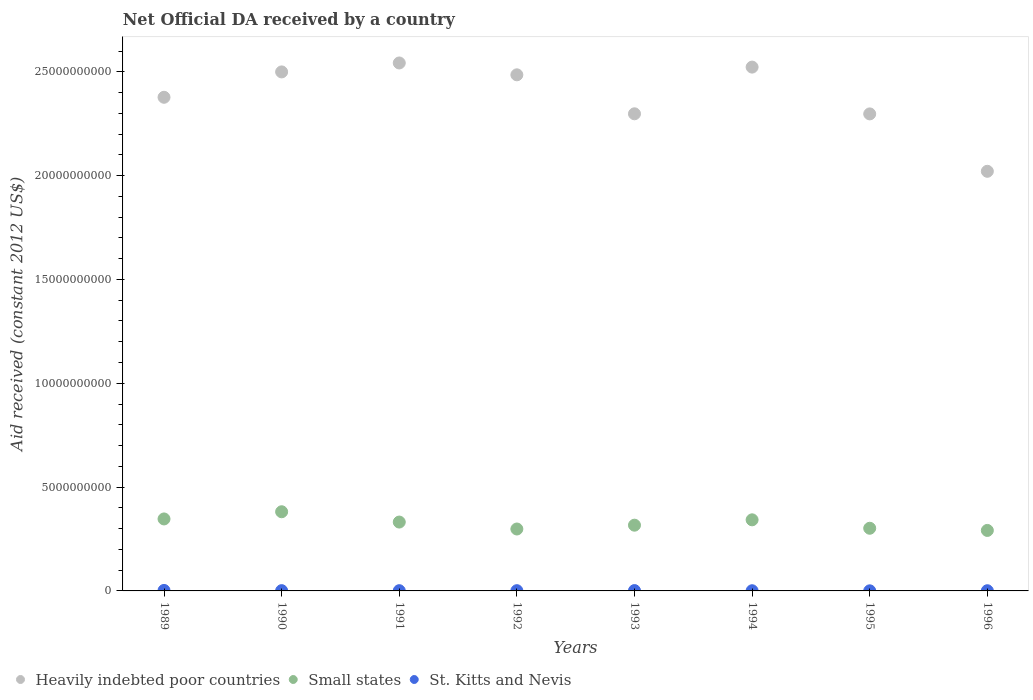How many different coloured dotlines are there?
Provide a succinct answer. 3. What is the net official development assistance aid received in St. Kitts and Nevis in 1994?
Provide a succinct answer. 9.11e+06. Across all years, what is the maximum net official development assistance aid received in Heavily indebted poor countries?
Offer a very short reply. 2.54e+1. Across all years, what is the minimum net official development assistance aid received in Small states?
Provide a short and direct response. 2.91e+09. In which year was the net official development assistance aid received in Small states maximum?
Offer a very short reply. 1990. In which year was the net official development assistance aid received in Small states minimum?
Your response must be concise. 1996. What is the total net official development assistance aid received in St. Kitts and Nevis in the graph?
Offer a terse response. 9.91e+07. What is the difference between the net official development assistance aid received in Heavily indebted poor countries in 1991 and that in 1992?
Keep it short and to the point. 5.71e+08. What is the difference between the net official development assistance aid received in Heavily indebted poor countries in 1991 and the net official development assistance aid received in Small states in 1989?
Keep it short and to the point. 2.20e+1. What is the average net official development assistance aid received in St. Kitts and Nevis per year?
Keep it short and to the point. 1.24e+07. In the year 1992, what is the difference between the net official development assistance aid received in Small states and net official development assistance aid received in Heavily indebted poor countries?
Give a very brief answer. -2.19e+1. In how many years, is the net official development assistance aid received in Small states greater than 5000000000 US$?
Keep it short and to the point. 0. What is the ratio of the net official development assistance aid received in Small states in 1991 to that in 1992?
Provide a succinct answer. 1.11. Is the net official development assistance aid received in Heavily indebted poor countries in 1992 less than that in 1995?
Your answer should be very brief. No. Is the difference between the net official development assistance aid received in Small states in 1992 and 1996 greater than the difference between the net official development assistance aid received in Heavily indebted poor countries in 1992 and 1996?
Provide a succinct answer. No. What is the difference between the highest and the second highest net official development assistance aid received in Small states?
Provide a short and direct response. 3.46e+08. What is the difference between the highest and the lowest net official development assistance aid received in St. Kitts and Nevis?
Offer a terse response. 1.82e+07. In how many years, is the net official development assistance aid received in Small states greater than the average net official development assistance aid received in Small states taken over all years?
Offer a very short reply. 4. Is it the case that in every year, the sum of the net official development assistance aid received in Small states and net official development assistance aid received in Heavily indebted poor countries  is greater than the net official development assistance aid received in St. Kitts and Nevis?
Your answer should be compact. Yes. Does the net official development assistance aid received in St. Kitts and Nevis monotonically increase over the years?
Keep it short and to the point. No. Is the net official development assistance aid received in Small states strictly greater than the net official development assistance aid received in Heavily indebted poor countries over the years?
Your answer should be very brief. No. Is the net official development assistance aid received in St. Kitts and Nevis strictly less than the net official development assistance aid received in Heavily indebted poor countries over the years?
Your response must be concise. Yes. How many dotlines are there?
Offer a very short reply. 3. How many years are there in the graph?
Provide a short and direct response. 8. What is the difference between two consecutive major ticks on the Y-axis?
Keep it short and to the point. 5.00e+09. Are the values on the major ticks of Y-axis written in scientific E-notation?
Make the answer very short. No. Does the graph contain grids?
Provide a succinct answer. No. Where does the legend appear in the graph?
Your answer should be very brief. Bottom left. How many legend labels are there?
Your response must be concise. 3. How are the legend labels stacked?
Provide a succinct answer. Horizontal. What is the title of the graph?
Provide a short and direct response. Net Official DA received by a country. What is the label or title of the X-axis?
Provide a succinct answer. Years. What is the label or title of the Y-axis?
Keep it short and to the point. Aid received (constant 2012 US$). What is the Aid received (constant 2012 US$) in Heavily indebted poor countries in 1989?
Ensure brevity in your answer.  2.38e+1. What is the Aid received (constant 2012 US$) in Small states in 1989?
Ensure brevity in your answer.  3.47e+09. What is the Aid received (constant 2012 US$) in St. Kitts and Nevis in 1989?
Keep it short and to the point. 2.32e+07. What is the Aid received (constant 2012 US$) of Heavily indebted poor countries in 1990?
Ensure brevity in your answer.  2.50e+1. What is the Aid received (constant 2012 US$) of Small states in 1990?
Keep it short and to the point. 3.81e+09. What is the Aid received (constant 2012 US$) of St. Kitts and Nevis in 1990?
Offer a very short reply. 1.31e+07. What is the Aid received (constant 2012 US$) of Heavily indebted poor countries in 1991?
Keep it short and to the point. 2.54e+1. What is the Aid received (constant 2012 US$) in Small states in 1991?
Keep it short and to the point. 3.32e+09. What is the Aid received (constant 2012 US$) of St. Kitts and Nevis in 1991?
Your answer should be very brief. 1.15e+07. What is the Aid received (constant 2012 US$) in Heavily indebted poor countries in 1992?
Provide a short and direct response. 2.49e+1. What is the Aid received (constant 2012 US$) of Small states in 1992?
Make the answer very short. 2.98e+09. What is the Aid received (constant 2012 US$) in St. Kitts and Nevis in 1992?
Make the answer very short. 1.18e+07. What is the Aid received (constant 2012 US$) of Heavily indebted poor countries in 1993?
Offer a very short reply. 2.30e+1. What is the Aid received (constant 2012 US$) in Small states in 1993?
Provide a succinct answer. 3.17e+09. What is the Aid received (constant 2012 US$) in St. Kitts and Nevis in 1993?
Your answer should be compact. 1.62e+07. What is the Aid received (constant 2012 US$) of Heavily indebted poor countries in 1994?
Keep it short and to the point. 2.52e+1. What is the Aid received (constant 2012 US$) of Small states in 1994?
Ensure brevity in your answer.  3.42e+09. What is the Aid received (constant 2012 US$) in St. Kitts and Nevis in 1994?
Offer a very short reply. 9.11e+06. What is the Aid received (constant 2012 US$) of Heavily indebted poor countries in 1995?
Your answer should be very brief. 2.30e+1. What is the Aid received (constant 2012 US$) in Small states in 1995?
Give a very brief answer. 3.02e+09. What is the Aid received (constant 2012 US$) of St. Kitts and Nevis in 1995?
Give a very brief answer. 5.01e+06. What is the Aid received (constant 2012 US$) in Heavily indebted poor countries in 1996?
Ensure brevity in your answer.  2.02e+1. What is the Aid received (constant 2012 US$) of Small states in 1996?
Provide a short and direct response. 2.91e+09. What is the Aid received (constant 2012 US$) in St. Kitts and Nevis in 1996?
Give a very brief answer. 9.19e+06. Across all years, what is the maximum Aid received (constant 2012 US$) of Heavily indebted poor countries?
Give a very brief answer. 2.54e+1. Across all years, what is the maximum Aid received (constant 2012 US$) of Small states?
Make the answer very short. 3.81e+09. Across all years, what is the maximum Aid received (constant 2012 US$) of St. Kitts and Nevis?
Your answer should be compact. 2.32e+07. Across all years, what is the minimum Aid received (constant 2012 US$) in Heavily indebted poor countries?
Make the answer very short. 2.02e+1. Across all years, what is the minimum Aid received (constant 2012 US$) of Small states?
Offer a terse response. 2.91e+09. Across all years, what is the minimum Aid received (constant 2012 US$) of St. Kitts and Nevis?
Provide a succinct answer. 5.01e+06. What is the total Aid received (constant 2012 US$) of Heavily indebted poor countries in the graph?
Offer a very short reply. 1.90e+11. What is the total Aid received (constant 2012 US$) in Small states in the graph?
Offer a terse response. 2.61e+1. What is the total Aid received (constant 2012 US$) of St. Kitts and Nevis in the graph?
Ensure brevity in your answer.  9.91e+07. What is the difference between the Aid received (constant 2012 US$) in Heavily indebted poor countries in 1989 and that in 1990?
Your answer should be very brief. -1.22e+09. What is the difference between the Aid received (constant 2012 US$) of Small states in 1989 and that in 1990?
Keep it short and to the point. -3.46e+08. What is the difference between the Aid received (constant 2012 US$) in St. Kitts and Nevis in 1989 and that in 1990?
Your answer should be compact. 1.01e+07. What is the difference between the Aid received (constant 2012 US$) of Heavily indebted poor countries in 1989 and that in 1991?
Keep it short and to the point. -1.65e+09. What is the difference between the Aid received (constant 2012 US$) of Small states in 1989 and that in 1991?
Make the answer very short. 1.50e+08. What is the difference between the Aid received (constant 2012 US$) in St. Kitts and Nevis in 1989 and that in 1991?
Provide a succinct answer. 1.17e+07. What is the difference between the Aid received (constant 2012 US$) of Heavily indebted poor countries in 1989 and that in 1992?
Provide a succinct answer. -1.08e+09. What is the difference between the Aid received (constant 2012 US$) in Small states in 1989 and that in 1992?
Make the answer very short. 4.85e+08. What is the difference between the Aid received (constant 2012 US$) in St. Kitts and Nevis in 1989 and that in 1992?
Your answer should be very brief. 1.14e+07. What is the difference between the Aid received (constant 2012 US$) in Heavily indebted poor countries in 1989 and that in 1993?
Provide a short and direct response. 7.96e+08. What is the difference between the Aid received (constant 2012 US$) in Small states in 1989 and that in 1993?
Give a very brief answer. 3.01e+08. What is the difference between the Aid received (constant 2012 US$) of St. Kitts and Nevis in 1989 and that in 1993?
Offer a terse response. 6.94e+06. What is the difference between the Aid received (constant 2012 US$) in Heavily indebted poor countries in 1989 and that in 1994?
Provide a short and direct response. -1.45e+09. What is the difference between the Aid received (constant 2012 US$) in Small states in 1989 and that in 1994?
Provide a succinct answer. 4.28e+07. What is the difference between the Aid received (constant 2012 US$) of St. Kitts and Nevis in 1989 and that in 1994?
Your answer should be very brief. 1.41e+07. What is the difference between the Aid received (constant 2012 US$) in Heavily indebted poor countries in 1989 and that in 1995?
Your answer should be compact. 8.00e+08. What is the difference between the Aid received (constant 2012 US$) in Small states in 1989 and that in 1995?
Your answer should be compact. 4.49e+08. What is the difference between the Aid received (constant 2012 US$) of St. Kitts and Nevis in 1989 and that in 1995?
Give a very brief answer. 1.82e+07. What is the difference between the Aid received (constant 2012 US$) in Heavily indebted poor countries in 1989 and that in 1996?
Your response must be concise. 3.56e+09. What is the difference between the Aid received (constant 2012 US$) in Small states in 1989 and that in 1996?
Offer a very short reply. 5.54e+08. What is the difference between the Aid received (constant 2012 US$) of St. Kitts and Nevis in 1989 and that in 1996?
Offer a terse response. 1.40e+07. What is the difference between the Aid received (constant 2012 US$) in Heavily indebted poor countries in 1990 and that in 1991?
Provide a short and direct response. -4.31e+08. What is the difference between the Aid received (constant 2012 US$) in Small states in 1990 and that in 1991?
Your answer should be very brief. 4.96e+08. What is the difference between the Aid received (constant 2012 US$) of St. Kitts and Nevis in 1990 and that in 1991?
Offer a very short reply. 1.62e+06. What is the difference between the Aid received (constant 2012 US$) of Heavily indebted poor countries in 1990 and that in 1992?
Your answer should be compact. 1.40e+08. What is the difference between the Aid received (constant 2012 US$) in Small states in 1990 and that in 1992?
Keep it short and to the point. 8.31e+08. What is the difference between the Aid received (constant 2012 US$) of St. Kitts and Nevis in 1990 and that in 1992?
Ensure brevity in your answer.  1.35e+06. What is the difference between the Aid received (constant 2012 US$) in Heavily indebted poor countries in 1990 and that in 1993?
Your response must be concise. 2.02e+09. What is the difference between the Aid received (constant 2012 US$) of Small states in 1990 and that in 1993?
Provide a short and direct response. 6.47e+08. What is the difference between the Aid received (constant 2012 US$) in St. Kitts and Nevis in 1990 and that in 1993?
Give a very brief answer. -3.14e+06. What is the difference between the Aid received (constant 2012 US$) in Heavily indebted poor countries in 1990 and that in 1994?
Keep it short and to the point. -2.32e+08. What is the difference between the Aid received (constant 2012 US$) of Small states in 1990 and that in 1994?
Your answer should be compact. 3.89e+08. What is the difference between the Aid received (constant 2012 US$) of Heavily indebted poor countries in 1990 and that in 1995?
Keep it short and to the point. 2.02e+09. What is the difference between the Aid received (constant 2012 US$) of Small states in 1990 and that in 1995?
Keep it short and to the point. 7.95e+08. What is the difference between the Aid received (constant 2012 US$) of St. Kitts and Nevis in 1990 and that in 1995?
Your answer should be compact. 8.10e+06. What is the difference between the Aid received (constant 2012 US$) of Heavily indebted poor countries in 1990 and that in 1996?
Make the answer very short. 4.79e+09. What is the difference between the Aid received (constant 2012 US$) of Small states in 1990 and that in 1996?
Offer a very short reply. 8.99e+08. What is the difference between the Aid received (constant 2012 US$) of St. Kitts and Nevis in 1990 and that in 1996?
Your response must be concise. 3.92e+06. What is the difference between the Aid received (constant 2012 US$) in Heavily indebted poor countries in 1991 and that in 1992?
Your answer should be very brief. 5.71e+08. What is the difference between the Aid received (constant 2012 US$) of Small states in 1991 and that in 1992?
Keep it short and to the point. 3.34e+08. What is the difference between the Aid received (constant 2012 US$) in Heavily indebted poor countries in 1991 and that in 1993?
Ensure brevity in your answer.  2.45e+09. What is the difference between the Aid received (constant 2012 US$) in Small states in 1991 and that in 1993?
Give a very brief answer. 1.50e+08. What is the difference between the Aid received (constant 2012 US$) of St. Kitts and Nevis in 1991 and that in 1993?
Your answer should be very brief. -4.76e+06. What is the difference between the Aid received (constant 2012 US$) in Heavily indebted poor countries in 1991 and that in 1994?
Offer a very short reply. 1.99e+08. What is the difference between the Aid received (constant 2012 US$) in Small states in 1991 and that in 1994?
Ensure brevity in your answer.  -1.08e+08. What is the difference between the Aid received (constant 2012 US$) in St. Kitts and Nevis in 1991 and that in 1994?
Your response must be concise. 2.38e+06. What is the difference between the Aid received (constant 2012 US$) in Heavily indebted poor countries in 1991 and that in 1995?
Provide a short and direct response. 2.45e+09. What is the difference between the Aid received (constant 2012 US$) of Small states in 1991 and that in 1995?
Offer a terse response. 2.98e+08. What is the difference between the Aid received (constant 2012 US$) of St. Kitts and Nevis in 1991 and that in 1995?
Provide a short and direct response. 6.48e+06. What is the difference between the Aid received (constant 2012 US$) of Heavily indebted poor countries in 1991 and that in 1996?
Your answer should be compact. 5.22e+09. What is the difference between the Aid received (constant 2012 US$) of Small states in 1991 and that in 1996?
Make the answer very short. 4.03e+08. What is the difference between the Aid received (constant 2012 US$) in St. Kitts and Nevis in 1991 and that in 1996?
Your answer should be compact. 2.30e+06. What is the difference between the Aid received (constant 2012 US$) in Heavily indebted poor countries in 1992 and that in 1993?
Give a very brief answer. 1.88e+09. What is the difference between the Aid received (constant 2012 US$) in Small states in 1992 and that in 1993?
Keep it short and to the point. -1.84e+08. What is the difference between the Aid received (constant 2012 US$) of St. Kitts and Nevis in 1992 and that in 1993?
Your answer should be compact. -4.49e+06. What is the difference between the Aid received (constant 2012 US$) of Heavily indebted poor countries in 1992 and that in 1994?
Offer a terse response. -3.72e+08. What is the difference between the Aid received (constant 2012 US$) in Small states in 1992 and that in 1994?
Keep it short and to the point. -4.42e+08. What is the difference between the Aid received (constant 2012 US$) of St. Kitts and Nevis in 1992 and that in 1994?
Offer a very short reply. 2.65e+06. What is the difference between the Aid received (constant 2012 US$) in Heavily indebted poor countries in 1992 and that in 1995?
Keep it short and to the point. 1.88e+09. What is the difference between the Aid received (constant 2012 US$) of Small states in 1992 and that in 1995?
Ensure brevity in your answer.  -3.59e+07. What is the difference between the Aid received (constant 2012 US$) in St. Kitts and Nevis in 1992 and that in 1995?
Offer a terse response. 6.75e+06. What is the difference between the Aid received (constant 2012 US$) in Heavily indebted poor countries in 1992 and that in 1996?
Your answer should be very brief. 4.65e+09. What is the difference between the Aid received (constant 2012 US$) in Small states in 1992 and that in 1996?
Offer a terse response. 6.89e+07. What is the difference between the Aid received (constant 2012 US$) of St. Kitts and Nevis in 1992 and that in 1996?
Ensure brevity in your answer.  2.57e+06. What is the difference between the Aid received (constant 2012 US$) of Heavily indebted poor countries in 1993 and that in 1994?
Your answer should be compact. -2.25e+09. What is the difference between the Aid received (constant 2012 US$) in Small states in 1993 and that in 1994?
Make the answer very short. -2.58e+08. What is the difference between the Aid received (constant 2012 US$) of St. Kitts and Nevis in 1993 and that in 1994?
Offer a very short reply. 7.14e+06. What is the difference between the Aid received (constant 2012 US$) in Heavily indebted poor countries in 1993 and that in 1995?
Make the answer very short. 4.75e+06. What is the difference between the Aid received (constant 2012 US$) in Small states in 1993 and that in 1995?
Offer a very short reply. 1.48e+08. What is the difference between the Aid received (constant 2012 US$) in St. Kitts and Nevis in 1993 and that in 1995?
Provide a short and direct response. 1.12e+07. What is the difference between the Aid received (constant 2012 US$) of Heavily indebted poor countries in 1993 and that in 1996?
Your response must be concise. 2.77e+09. What is the difference between the Aid received (constant 2012 US$) in Small states in 1993 and that in 1996?
Keep it short and to the point. 2.53e+08. What is the difference between the Aid received (constant 2012 US$) in St. Kitts and Nevis in 1993 and that in 1996?
Give a very brief answer. 7.06e+06. What is the difference between the Aid received (constant 2012 US$) of Heavily indebted poor countries in 1994 and that in 1995?
Make the answer very short. 2.25e+09. What is the difference between the Aid received (constant 2012 US$) in Small states in 1994 and that in 1995?
Offer a very short reply. 4.06e+08. What is the difference between the Aid received (constant 2012 US$) in St. Kitts and Nevis in 1994 and that in 1995?
Offer a terse response. 4.10e+06. What is the difference between the Aid received (constant 2012 US$) in Heavily indebted poor countries in 1994 and that in 1996?
Your response must be concise. 5.02e+09. What is the difference between the Aid received (constant 2012 US$) in Small states in 1994 and that in 1996?
Make the answer very short. 5.11e+08. What is the difference between the Aid received (constant 2012 US$) in St. Kitts and Nevis in 1994 and that in 1996?
Offer a terse response. -8.00e+04. What is the difference between the Aid received (constant 2012 US$) of Heavily indebted poor countries in 1995 and that in 1996?
Offer a terse response. 2.76e+09. What is the difference between the Aid received (constant 2012 US$) of Small states in 1995 and that in 1996?
Keep it short and to the point. 1.05e+08. What is the difference between the Aid received (constant 2012 US$) in St. Kitts and Nevis in 1995 and that in 1996?
Offer a terse response. -4.18e+06. What is the difference between the Aid received (constant 2012 US$) in Heavily indebted poor countries in 1989 and the Aid received (constant 2012 US$) in Small states in 1990?
Make the answer very short. 2.00e+1. What is the difference between the Aid received (constant 2012 US$) in Heavily indebted poor countries in 1989 and the Aid received (constant 2012 US$) in St. Kitts and Nevis in 1990?
Ensure brevity in your answer.  2.38e+1. What is the difference between the Aid received (constant 2012 US$) of Small states in 1989 and the Aid received (constant 2012 US$) of St. Kitts and Nevis in 1990?
Make the answer very short. 3.45e+09. What is the difference between the Aid received (constant 2012 US$) in Heavily indebted poor countries in 1989 and the Aid received (constant 2012 US$) in Small states in 1991?
Your answer should be very brief. 2.05e+1. What is the difference between the Aid received (constant 2012 US$) of Heavily indebted poor countries in 1989 and the Aid received (constant 2012 US$) of St. Kitts and Nevis in 1991?
Make the answer very short. 2.38e+1. What is the difference between the Aid received (constant 2012 US$) of Small states in 1989 and the Aid received (constant 2012 US$) of St. Kitts and Nevis in 1991?
Provide a short and direct response. 3.46e+09. What is the difference between the Aid received (constant 2012 US$) of Heavily indebted poor countries in 1989 and the Aid received (constant 2012 US$) of Small states in 1992?
Provide a succinct answer. 2.08e+1. What is the difference between the Aid received (constant 2012 US$) in Heavily indebted poor countries in 1989 and the Aid received (constant 2012 US$) in St. Kitts and Nevis in 1992?
Make the answer very short. 2.38e+1. What is the difference between the Aid received (constant 2012 US$) in Small states in 1989 and the Aid received (constant 2012 US$) in St. Kitts and Nevis in 1992?
Your answer should be compact. 3.45e+09. What is the difference between the Aid received (constant 2012 US$) in Heavily indebted poor countries in 1989 and the Aid received (constant 2012 US$) in Small states in 1993?
Ensure brevity in your answer.  2.06e+1. What is the difference between the Aid received (constant 2012 US$) of Heavily indebted poor countries in 1989 and the Aid received (constant 2012 US$) of St. Kitts and Nevis in 1993?
Give a very brief answer. 2.38e+1. What is the difference between the Aid received (constant 2012 US$) of Small states in 1989 and the Aid received (constant 2012 US$) of St. Kitts and Nevis in 1993?
Provide a short and direct response. 3.45e+09. What is the difference between the Aid received (constant 2012 US$) of Heavily indebted poor countries in 1989 and the Aid received (constant 2012 US$) of Small states in 1994?
Keep it short and to the point. 2.03e+1. What is the difference between the Aid received (constant 2012 US$) of Heavily indebted poor countries in 1989 and the Aid received (constant 2012 US$) of St. Kitts and Nevis in 1994?
Give a very brief answer. 2.38e+1. What is the difference between the Aid received (constant 2012 US$) in Small states in 1989 and the Aid received (constant 2012 US$) in St. Kitts and Nevis in 1994?
Make the answer very short. 3.46e+09. What is the difference between the Aid received (constant 2012 US$) in Heavily indebted poor countries in 1989 and the Aid received (constant 2012 US$) in Small states in 1995?
Ensure brevity in your answer.  2.08e+1. What is the difference between the Aid received (constant 2012 US$) of Heavily indebted poor countries in 1989 and the Aid received (constant 2012 US$) of St. Kitts and Nevis in 1995?
Offer a very short reply. 2.38e+1. What is the difference between the Aid received (constant 2012 US$) in Small states in 1989 and the Aid received (constant 2012 US$) in St. Kitts and Nevis in 1995?
Give a very brief answer. 3.46e+09. What is the difference between the Aid received (constant 2012 US$) in Heavily indebted poor countries in 1989 and the Aid received (constant 2012 US$) in Small states in 1996?
Give a very brief answer. 2.09e+1. What is the difference between the Aid received (constant 2012 US$) of Heavily indebted poor countries in 1989 and the Aid received (constant 2012 US$) of St. Kitts and Nevis in 1996?
Your answer should be very brief. 2.38e+1. What is the difference between the Aid received (constant 2012 US$) in Small states in 1989 and the Aid received (constant 2012 US$) in St. Kitts and Nevis in 1996?
Keep it short and to the point. 3.46e+09. What is the difference between the Aid received (constant 2012 US$) of Heavily indebted poor countries in 1990 and the Aid received (constant 2012 US$) of Small states in 1991?
Provide a succinct answer. 2.17e+1. What is the difference between the Aid received (constant 2012 US$) of Heavily indebted poor countries in 1990 and the Aid received (constant 2012 US$) of St. Kitts and Nevis in 1991?
Your answer should be compact. 2.50e+1. What is the difference between the Aid received (constant 2012 US$) in Small states in 1990 and the Aid received (constant 2012 US$) in St. Kitts and Nevis in 1991?
Your answer should be very brief. 3.80e+09. What is the difference between the Aid received (constant 2012 US$) of Heavily indebted poor countries in 1990 and the Aid received (constant 2012 US$) of Small states in 1992?
Give a very brief answer. 2.20e+1. What is the difference between the Aid received (constant 2012 US$) in Heavily indebted poor countries in 1990 and the Aid received (constant 2012 US$) in St. Kitts and Nevis in 1992?
Your response must be concise. 2.50e+1. What is the difference between the Aid received (constant 2012 US$) of Small states in 1990 and the Aid received (constant 2012 US$) of St. Kitts and Nevis in 1992?
Your response must be concise. 3.80e+09. What is the difference between the Aid received (constant 2012 US$) of Heavily indebted poor countries in 1990 and the Aid received (constant 2012 US$) of Small states in 1993?
Your answer should be compact. 2.18e+1. What is the difference between the Aid received (constant 2012 US$) in Heavily indebted poor countries in 1990 and the Aid received (constant 2012 US$) in St. Kitts and Nevis in 1993?
Your answer should be compact. 2.50e+1. What is the difference between the Aid received (constant 2012 US$) of Small states in 1990 and the Aid received (constant 2012 US$) of St. Kitts and Nevis in 1993?
Make the answer very short. 3.80e+09. What is the difference between the Aid received (constant 2012 US$) of Heavily indebted poor countries in 1990 and the Aid received (constant 2012 US$) of Small states in 1994?
Your answer should be compact. 2.16e+1. What is the difference between the Aid received (constant 2012 US$) in Heavily indebted poor countries in 1990 and the Aid received (constant 2012 US$) in St. Kitts and Nevis in 1994?
Make the answer very short. 2.50e+1. What is the difference between the Aid received (constant 2012 US$) in Small states in 1990 and the Aid received (constant 2012 US$) in St. Kitts and Nevis in 1994?
Offer a terse response. 3.80e+09. What is the difference between the Aid received (constant 2012 US$) in Heavily indebted poor countries in 1990 and the Aid received (constant 2012 US$) in Small states in 1995?
Keep it short and to the point. 2.20e+1. What is the difference between the Aid received (constant 2012 US$) in Heavily indebted poor countries in 1990 and the Aid received (constant 2012 US$) in St. Kitts and Nevis in 1995?
Offer a very short reply. 2.50e+1. What is the difference between the Aid received (constant 2012 US$) in Small states in 1990 and the Aid received (constant 2012 US$) in St. Kitts and Nevis in 1995?
Make the answer very short. 3.81e+09. What is the difference between the Aid received (constant 2012 US$) of Heavily indebted poor countries in 1990 and the Aid received (constant 2012 US$) of Small states in 1996?
Offer a very short reply. 2.21e+1. What is the difference between the Aid received (constant 2012 US$) in Heavily indebted poor countries in 1990 and the Aid received (constant 2012 US$) in St. Kitts and Nevis in 1996?
Your response must be concise. 2.50e+1. What is the difference between the Aid received (constant 2012 US$) of Small states in 1990 and the Aid received (constant 2012 US$) of St. Kitts and Nevis in 1996?
Give a very brief answer. 3.80e+09. What is the difference between the Aid received (constant 2012 US$) in Heavily indebted poor countries in 1991 and the Aid received (constant 2012 US$) in Small states in 1992?
Your answer should be compact. 2.24e+1. What is the difference between the Aid received (constant 2012 US$) in Heavily indebted poor countries in 1991 and the Aid received (constant 2012 US$) in St. Kitts and Nevis in 1992?
Offer a terse response. 2.54e+1. What is the difference between the Aid received (constant 2012 US$) in Small states in 1991 and the Aid received (constant 2012 US$) in St. Kitts and Nevis in 1992?
Your answer should be very brief. 3.30e+09. What is the difference between the Aid received (constant 2012 US$) of Heavily indebted poor countries in 1991 and the Aid received (constant 2012 US$) of Small states in 1993?
Ensure brevity in your answer.  2.23e+1. What is the difference between the Aid received (constant 2012 US$) in Heavily indebted poor countries in 1991 and the Aid received (constant 2012 US$) in St. Kitts and Nevis in 1993?
Keep it short and to the point. 2.54e+1. What is the difference between the Aid received (constant 2012 US$) in Small states in 1991 and the Aid received (constant 2012 US$) in St. Kitts and Nevis in 1993?
Provide a succinct answer. 3.30e+09. What is the difference between the Aid received (constant 2012 US$) in Heavily indebted poor countries in 1991 and the Aid received (constant 2012 US$) in Small states in 1994?
Offer a very short reply. 2.20e+1. What is the difference between the Aid received (constant 2012 US$) in Heavily indebted poor countries in 1991 and the Aid received (constant 2012 US$) in St. Kitts and Nevis in 1994?
Your answer should be compact. 2.54e+1. What is the difference between the Aid received (constant 2012 US$) in Small states in 1991 and the Aid received (constant 2012 US$) in St. Kitts and Nevis in 1994?
Ensure brevity in your answer.  3.31e+09. What is the difference between the Aid received (constant 2012 US$) of Heavily indebted poor countries in 1991 and the Aid received (constant 2012 US$) of Small states in 1995?
Keep it short and to the point. 2.24e+1. What is the difference between the Aid received (constant 2012 US$) of Heavily indebted poor countries in 1991 and the Aid received (constant 2012 US$) of St. Kitts and Nevis in 1995?
Your answer should be very brief. 2.54e+1. What is the difference between the Aid received (constant 2012 US$) of Small states in 1991 and the Aid received (constant 2012 US$) of St. Kitts and Nevis in 1995?
Keep it short and to the point. 3.31e+09. What is the difference between the Aid received (constant 2012 US$) of Heavily indebted poor countries in 1991 and the Aid received (constant 2012 US$) of Small states in 1996?
Keep it short and to the point. 2.25e+1. What is the difference between the Aid received (constant 2012 US$) in Heavily indebted poor countries in 1991 and the Aid received (constant 2012 US$) in St. Kitts and Nevis in 1996?
Make the answer very short. 2.54e+1. What is the difference between the Aid received (constant 2012 US$) in Small states in 1991 and the Aid received (constant 2012 US$) in St. Kitts and Nevis in 1996?
Provide a succinct answer. 3.31e+09. What is the difference between the Aid received (constant 2012 US$) of Heavily indebted poor countries in 1992 and the Aid received (constant 2012 US$) of Small states in 1993?
Make the answer very short. 2.17e+1. What is the difference between the Aid received (constant 2012 US$) in Heavily indebted poor countries in 1992 and the Aid received (constant 2012 US$) in St. Kitts and Nevis in 1993?
Give a very brief answer. 2.48e+1. What is the difference between the Aid received (constant 2012 US$) of Small states in 1992 and the Aid received (constant 2012 US$) of St. Kitts and Nevis in 1993?
Provide a short and direct response. 2.97e+09. What is the difference between the Aid received (constant 2012 US$) of Heavily indebted poor countries in 1992 and the Aid received (constant 2012 US$) of Small states in 1994?
Your answer should be very brief. 2.14e+1. What is the difference between the Aid received (constant 2012 US$) of Heavily indebted poor countries in 1992 and the Aid received (constant 2012 US$) of St. Kitts and Nevis in 1994?
Offer a terse response. 2.48e+1. What is the difference between the Aid received (constant 2012 US$) in Small states in 1992 and the Aid received (constant 2012 US$) in St. Kitts and Nevis in 1994?
Offer a terse response. 2.97e+09. What is the difference between the Aid received (constant 2012 US$) in Heavily indebted poor countries in 1992 and the Aid received (constant 2012 US$) in Small states in 1995?
Make the answer very short. 2.18e+1. What is the difference between the Aid received (constant 2012 US$) in Heavily indebted poor countries in 1992 and the Aid received (constant 2012 US$) in St. Kitts and Nevis in 1995?
Your answer should be compact. 2.48e+1. What is the difference between the Aid received (constant 2012 US$) in Small states in 1992 and the Aid received (constant 2012 US$) in St. Kitts and Nevis in 1995?
Ensure brevity in your answer.  2.98e+09. What is the difference between the Aid received (constant 2012 US$) in Heavily indebted poor countries in 1992 and the Aid received (constant 2012 US$) in Small states in 1996?
Offer a terse response. 2.19e+1. What is the difference between the Aid received (constant 2012 US$) in Heavily indebted poor countries in 1992 and the Aid received (constant 2012 US$) in St. Kitts and Nevis in 1996?
Ensure brevity in your answer.  2.48e+1. What is the difference between the Aid received (constant 2012 US$) of Small states in 1992 and the Aid received (constant 2012 US$) of St. Kitts and Nevis in 1996?
Offer a terse response. 2.97e+09. What is the difference between the Aid received (constant 2012 US$) of Heavily indebted poor countries in 1993 and the Aid received (constant 2012 US$) of Small states in 1994?
Make the answer very short. 1.96e+1. What is the difference between the Aid received (constant 2012 US$) in Heavily indebted poor countries in 1993 and the Aid received (constant 2012 US$) in St. Kitts and Nevis in 1994?
Offer a very short reply. 2.30e+1. What is the difference between the Aid received (constant 2012 US$) of Small states in 1993 and the Aid received (constant 2012 US$) of St. Kitts and Nevis in 1994?
Your answer should be very brief. 3.16e+09. What is the difference between the Aid received (constant 2012 US$) in Heavily indebted poor countries in 1993 and the Aid received (constant 2012 US$) in Small states in 1995?
Keep it short and to the point. 2.00e+1. What is the difference between the Aid received (constant 2012 US$) in Heavily indebted poor countries in 1993 and the Aid received (constant 2012 US$) in St. Kitts and Nevis in 1995?
Give a very brief answer. 2.30e+1. What is the difference between the Aid received (constant 2012 US$) in Small states in 1993 and the Aid received (constant 2012 US$) in St. Kitts and Nevis in 1995?
Your answer should be very brief. 3.16e+09. What is the difference between the Aid received (constant 2012 US$) in Heavily indebted poor countries in 1993 and the Aid received (constant 2012 US$) in Small states in 1996?
Your answer should be very brief. 2.01e+1. What is the difference between the Aid received (constant 2012 US$) of Heavily indebted poor countries in 1993 and the Aid received (constant 2012 US$) of St. Kitts and Nevis in 1996?
Offer a terse response. 2.30e+1. What is the difference between the Aid received (constant 2012 US$) of Small states in 1993 and the Aid received (constant 2012 US$) of St. Kitts and Nevis in 1996?
Offer a terse response. 3.16e+09. What is the difference between the Aid received (constant 2012 US$) in Heavily indebted poor countries in 1994 and the Aid received (constant 2012 US$) in Small states in 1995?
Your answer should be very brief. 2.22e+1. What is the difference between the Aid received (constant 2012 US$) of Heavily indebted poor countries in 1994 and the Aid received (constant 2012 US$) of St. Kitts and Nevis in 1995?
Offer a terse response. 2.52e+1. What is the difference between the Aid received (constant 2012 US$) in Small states in 1994 and the Aid received (constant 2012 US$) in St. Kitts and Nevis in 1995?
Offer a terse response. 3.42e+09. What is the difference between the Aid received (constant 2012 US$) in Heavily indebted poor countries in 1994 and the Aid received (constant 2012 US$) in Small states in 1996?
Your answer should be compact. 2.23e+1. What is the difference between the Aid received (constant 2012 US$) in Heavily indebted poor countries in 1994 and the Aid received (constant 2012 US$) in St. Kitts and Nevis in 1996?
Your response must be concise. 2.52e+1. What is the difference between the Aid received (constant 2012 US$) of Small states in 1994 and the Aid received (constant 2012 US$) of St. Kitts and Nevis in 1996?
Give a very brief answer. 3.41e+09. What is the difference between the Aid received (constant 2012 US$) of Heavily indebted poor countries in 1995 and the Aid received (constant 2012 US$) of Small states in 1996?
Offer a very short reply. 2.01e+1. What is the difference between the Aid received (constant 2012 US$) in Heavily indebted poor countries in 1995 and the Aid received (constant 2012 US$) in St. Kitts and Nevis in 1996?
Offer a very short reply. 2.30e+1. What is the difference between the Aid received (constant 2012 US$) in Small states in 1995 and the Aid received (constant 2012 US$) in St. Kitts and Nevis in 1996?
Keep it short and to the point. 3.01e+09. What is the average Aid received (constant 2012 US$) of Heavily indebted poor countries per year?
Offer a very short reply. 2.38e+1. What is the average Aid received (constant 2012 US$) in Small states per year?
Provide a succinct answer. 3.26e+09. What is the average Aid received (constant 2012 US$) of St. Kitts and Nevis per year?
Provide a short and direct response. 1.24e+07. In the year 1989, what is the difference between the Aid received (constant 2012 US$) in Heavily indebted poor countries and Aid received (constant 2012 US$) in Small states?
Keep it short and to the point. 2.03e+1. In the year 1989, what is the difference between the Aid received (constant 2012 US$) in Heavily indebted poor countries and Aid received (constant 2012 US$) in St. Kitts and Nevis?
Offer a very short reply. 2.37e+1. In the year 1989, what is the difference between the Aid received (constant 2012 US$) in Small states and Aid received (constant 2012 US$) in St. Kitts and Nevis?
Keep it short and to the point. 3.44e+09. In the year 1990, what is the difference between the Aid received (constant 2012 US$) of Heavily indebted poor countries and Aid received (constant 2012 US$) of Small states?
Offer a very short reply. 2.12e+1. In the year 1990, what is the difference between the Aid received (constant 2012 US$) of Heavily indebted poor countries and Aid received (constant 2012 US$) of St. Kitts and Nevis?
Your response must be concise. 2.50e+1. In the year 1990, what is the difference between the Aid received (constant 2012 US$) of Small states and Aid received (constant 2012 US$) of St. Kitts and Nevis?
Make the answer very short. 3.80e+09. In the year 1991, what is the difference between the Aid received (constant 2012 US$) in Heavily indebted poor countries and Aid received (constant 2012 US$) in Small states?
Your response must be concise. 2.21e+1. In the year 1991, what is the difference between the Aid received (constant 2012 US$) of Heavily indebted poor countries and Aid received (constant 2012 US$) of St. Kitts and Nevis?
Your answer should be very brief. 2.54e+1. In the year 1991, what is the difference between the Aid received (constant 2012 US$) of Small states and Aid received (constant 2012 US$) of St. Kitts and Nevis?
Ensure brevity in your answer.  3.30e+09. In the year 1992, what is the difference between the Aid received (constant 2012 US$) in Heavily indebted poor countries and Aid received (constant 2012 US$) in Small states?
Ensure brevity in your answer.  2.19e+1. In the year 1992, what is the difference between the Aid received (constant 2012 US$) in Heavily indebted poor countries and Aid received (constant 2012 US$) in St. Kitts and Nevis?
Ensure brevity in your answer.  2.48e+1. In the year 1992, what is the difference between the Aid received (constant 2012 US$) in Small states and Aid received (constant 2012 US$) in St. Kitts and Nevis?
Offer a very short reply. 2.97e+09. In the year 1993, what is the difference between the Aid received (constant 2012 US$) of Heavily indebted poor countries and Aid received (constant 2012 US$) of Small states?
Offer a very short reply. 1.98e+1. In the year 1993, what is the difference between the Aid received (constant 2012 US$) in Heavily indebted poor countries and Aid received (constant 2012 US$) in St. Kitts and Nevis?
Your answer should be very brief. 2.30e+1. In the year 1993, what is the difference between the Aid received (constant 2012 US$) of Small states and Aid received (constant 2012 US$) of St. Kitts and Nevis?
Offer a terse response. 3.15e+09. In the year 1994, what is the difference between the Aid received (constant 2012 US$) in Heavily indebted poor countries and Aid received (constant 2012 US$) in Small states?
Ensure brevity in your answer.  2.18e+1. In the year 1994, what is the difference between the Aid received (constant 2012 US$) of Heavily indebted poor countries and Aid received (constant 2012 US$) of St. Kitts and Nevis?
Your answer should be very brief. 2.52e+1. In the year 1994, what is the difference between the Aid received (constant 2012 US$) in Small states and Aid received (constant 2012 US$) in St. Kitts and Nevis?
Your response must be concise. 3.41e+09. In the year 1995, what is the difference between the Aid received (constant 2012 US$) of Heavily indebted poor countries and Aid received (constant 2012 US$) of Small states?
Ensure brevity in your answer.  2.00e+1. In the year 1995, what is the difference between the Aid received (constant 2012 US$) in Heavily indebted poor countries and Aid received (constant 2012 US$) in St. Kitts and Nevis?
Provide a succinct answer. 2.30e+1. In the year 1995, what is the difference between the Aid received (constant 2012 US$) in Small states and Aid received (constant 2012 US$) in St. Kitts and Nevis?
Your answer should be very brief. 3.01e+09. In the year 1996, what is the difference between the Aid received (constant 2012 US$) of Heavily indebted poor countries and Aid received (constant 2012 US$) of Small states?
Your answer should be compact. 1.73e+1. In the year 1996, what is the difference between the Aid received (constant 2012 US$) of Heavily indebted poor countries and Aid received (constant 2012 US$) of St. Kitts and Nevis?
Give a very brief answer. 2.02e+1. In the year 1996, what is the difference between the Aid received (constant 2012 US$) of Small states and Aid received (constant 2012 US$) of St. Kitts and Nevis?
Make the answer very short. 2.90e+09. What is the ratio of the Aid received (constant 2012 US$) in Heavily indebted poor countries in 1989 to that in 1990?
Provide a short and direct response. 0.95. What is the ratio of the Aid received (constant 2012 US$) of Small states in 1989 to that in 1990?
Provide a short and direct response. 0.91. What is the ratio of the Aid received (constant 2012 US$) in St. Kitts and Nevis in 1989 to that in 1990?
Your answer should be very brief. 1.77. What is the ratio of the Aid received (constant 2012 US$) of Heavily indebted poor countries in 1989 to that in 1991?
Provide a short and direct response. 0.94. What is the ratio of the Aid received (constant 2012 US$) of Small states in 1989 to that in 1991?
Provide a short and direct response. 1.05. What is the ratio of the Aid received (constant 2012 US$) of St. Kitts and Nevis in 1989 to that in 1991?
Your response must be concise. 2.02. What is the ratio of the Aid received (constant 2012 US$) in Heavily indebted poor countries in 1989 to that in 1992?
Ensure brevity in your answer.  0.96. What is the ratio of the Aid received (constant 2012 US$) of Small states in 1989 to that in 1992?
Your answer should be compact. 1.16. What is the ratio of the Aid received (constant 2012 US$) in St. Kitts and Nevis in 1989 to that in 1992?
Keep it short and to the point. 1.97. What is the ratio of the Aid received (constant 2012 US$) of Heavily indebted poor countries in 1989 to that in 1993?
Give a very brief answer. 1.03. What is the ratio of the Aid received (constant 2012 US$) of Small states in 1989 to that in 1993?
Your answer should be very brief. 1.09. What is the ratio of the Aid received (constant 2012 US$) in St. Kitts and Nevis in 1989 to that in 1993?
Make the answer very short. 1.43. What is the ratio of the Aid received (constant 2012 US$) of Heavily indebted poor countries in 1989 to that in 1994?
Provide a succinct answer. 0.94. What is the ratio of the Aid received (constant 2012 US$) in Small states in 1989 to that in 1994?
Your response must be concise. 1.01. What is the ratio of the Aid received (constant 2012 US$) in St. Kitts and Nevis in 1989 to that in 1994?
Your answer should be compact. 2.55. What is the ratio of the Aid received (constant 2012 US$) in Heavily indebted poor countries in 1989 to that in 1995?
Offer a very short reply. 1.03. What is the ratio of the Aid received (constant 2012 US$) of Small states in 1989 to that in 1995?
Keep it short and to the point. 1.15. What is the ratio of the Aid received (constant 2012 US$) in St. Kitts and Nevis in 1989 to that in 1995?
Offer a very short reply. 4.63. What is the ratio of the Aid received (constant 2012 US$) in Heavily indebted poor countries in 1989 to that in 1996?
Provide a succinct answer. 1.18. What is the ratio of the Aid received (constant 2012 US$) in Small states in 1989 to that in 1996?
Keep it short and to the point. 1.19. What is the ratio of the Aid received (constant 2012 US$) in St. Kitts and Nevis in 1989 to that in 1996?
Ensure brevity in your answer.  2.52. What is the ratio of the Aid received (constant 2012 US$) in Heavily indebted poor countries in 1990 to that in 1991?
Keep it short and to the point. 0.98. What is the ratio of the Aid received (constant 2012 US$) in Small states in 1990 to that in 1991?
Your answer should be compact. 1.15. What is the ratio of the Aid received (constant 2012 US$) in St. Kitts and Nevis in 1990 to that in 1991?
Your answer should be compact. 1.14. What is the ratio of the Aid received (constant 2012 US$) in Heavily indebted poor countries in 1990 to that in 1992?
Make the answer very short. 1.01. What is the ratio of the Aid received (constant 2012 US$) in Small states in 1990 to that in 1992?
Offer a very short reply. 1.28. What is the ratio of the Aid received (constant 2012 US$) of St. Kitts and Nevis in 1990 to that in 1992?
Your response must be concise. 1.11. What is the ratio of the Aid received (constant 2012 US$) of Heavily indebted poor countries in 1990 to that in 1993?
Offer a very short reply. 1.09. What is the ratio of the Aid received (constant 2012 US$) of Small states in 1990 to that in 1993?
Ensure brevity in your answer.  1.2. What is the ratio of the Aid received (constant 2012 US$) of St. Kitts and Nevis in 1990 to that in 1993?
Give a very brief answer. 0.81. What is the ratio of the Aid received (constant 2012 US$) in Heavily indebted poor countries in 1990 to that in 1994?
Your answer should be very brief. 0.99. What is the ratio of the Aid received (constant 2012 US$) of Small states in 1990 to that in 1994?
Give a very brief answer. 1.11. What is the ratio of the Aid received (constant 2012 US$) in St. Kitts and Nevis in 1990 to that in 1994?
Give a very brief answer. 1.44. What is the ratio of the Aid received (constant 2012 US$) in Heavily indebted poor countries in 1990 to that in 1995?
Give a very brief answer. 1.09. What is the ratio of the Aid received (constant 2012 US$) of Small states in 1990 to that in 1995?
Give a very brief answer. 1.26. What is the ratio of the Aid received (constant 2012 US$) of St. Kitts and Nevis in 1990 to that in 1995?
Provide a succinct answer. 2.62. What is the ratio of the Aid received (constant 2012 US$) of Heavily indebted poor countries in 1990 to that in 1996?
Keep it short and to the point. 1.24. What is the ratio of the Aid received (constant 2012 US$) of Small states in 1990 to that in 1996?
Provide a short and direct response. 1.31. What is the ratio of the Aid received (constant 2012 US$) in St. Kitts and Nevis in 1990 to that in 1996?
Keep it short and to the point. 1.43. What is the ratio of the Aid received (constant 2012 US$) of Heavily indebted poor countries in 1991 to that in 1992?
Your answer should be compact. 1.02. What is the ratio of the Aid received (constant 2012 US$) in Small states in 1991 to that in 1992?
Provide a short and direct response. 1.11. What is the ratio of the Aid received (constant 2012 US$) of Heavily indebted poor countries in 1991 to that in 1993?
Keep it short and to the point. 1.11. What is the ratio of the Aid received (constant 2012 US$) in Small states in 1991 to that in 1993?
Make the answer very short. 1.05. What is the ratio of the Aid received (constant 2012 US$) of St. Kitts and Nevis in 1991 to that in 1993?
Keep it short and to the point. 0.71. What is the ratio of the Aid received (constant 2012 US$) in Heavily indebted poor countries in 1991 to that in 1994?
Ensure brevity in your answer.  1.01. What is the ratio of the Aid received (constant 2012 US$) of Small states in 1991 to that in 1994?
Offer a very short reply. 0.97. What is the ratio of the Aid received (constant 2012 US$) of St. Kitts and Nevis in 1991 to that in 1994?
Ensure brevity in your answer.  1.26. What is the ratio of the Aid received (constant 2012 US$) of Heavily indebted poor countries in 1991 to that in 1995?
Make the answer very short. 1.11. What is the ratio of the Aid received (constant 2012 US$) in Small states in 1991 to that in 1995?
Your response must be concise. 1.1. What is the ratio of the Aid received (constant 2012 US$) of St. Kitts and Nevis in 1991 to that in 1995?
Ensure brevity in your answer.  2.29. What is the ratio of the Aid received (constant 2012 US$) in Heavily indebted poor countries in 1991 to that in 1996?
Your answer should be compact. 1.26. What is the ratio of the Aid received (constant 2012 US$) of Small states in 1991 to that in 1996?
Keep it short and to the point. 1.14. What is the ratio of the Aid received (constant 2012 US$) of St. Kitts and Nevis in 1991 to that in 1996?
Ensure brevity in your answer.  1.25. What is the ratio of the Aid received (constant 2012 US$) of Heavily indebted poor countries in 1992 to that in 1993?
Your answer should be compact. 1.08. What is the ratio of the Aid received (constant 2012 US$) of Small states in 1992 to that in 1993?
Make the answer very short. 0.94. What is the ratio of the Aid received (constant 2012 US$) in St. Kitts and Nevis in 1992 to that in 1993?
Offer a very short reply. 0.72. What is the ratio of the Aid received (constant 2012 US$) of Small states in 1992 to that in 1994?
Provide a succinct answer. 0.87. What is the ratio of the Aid received (constant 2012 US$) of St. Kitts and Nevis in 1992 to that in 1994?
Your answer should be very brief. 1.29. What is the ratio of the Aid received (constant 2012 US$) of Heavily indebted poor countries in 1992 to that in 1995?
Offer a very short reply. 1.08. What is the ratio of the Aid received (constant 2012 US$) in Small states in 1992 to that in 1995?
Give a very brief answer. 0.99. What is the ratio of the Aid received (constant 2012 US$) in St. Kitts and Nevis in 1992 to that in 1995?
Offer a terse response. 2.35. What is the ratio of the Aid received (constant 2012 US$) in Heavily indebted poor countries in 1992 to that in 1996?
Ensure brevity in your answer.  1.23. What is the ratio of the Aid received (constant 2012 US$) in Small states in 1992 to that in 1996?
Offer a very short reply. 1.02. What is the ratio of the Aid received (constant 2012 US$) in St. Kitts and Nevis in 1992 to that in 1996?
Offer a very short reply. 1.28. What is the ratio of the Aid received (constant 2012 US$) of Heavily indebted poor countries in 1993 to that in 1994?
Give a very brief answer. 0.91. What is the ratio of the Aid received (constant 2012 US$) of Small states in 1993 to that in 1994?
Provide a short and direct response. 0.92. What is the ratio of the Aid received (constant 2012 US$) of St. Kitts and Nevis in 1993 to that in 1994?
Ensure brevity in your answer.  1.78. What is the ratio of the Aid received (constant 2012 US$) of Small states in 1993 to that in 1995?
Your answer should be very brief. 1.05. What is the ratio of the Aid received (constant 2012 US$) of St. Kitts and Nevis in 1993 to that in 1995?
Ensure brevity in your answer.  3.24. What is the ratio of the Aid received (constant 2012 US$) in Heavily indebted poor countries in 1993 to that in 1996?
Provide a succinct answer. 1.14. What is the ratio of the Aid received (constant 2012 US$) in Small states in 1993 to that in 1996?
Your answer should be compact. 1.09. What is the ratio of the Aid received (constant 2012 US$) in St. Kitts and Nevis in 1993 to that in 1996?
Give a very brief answer. 1.77. What is the ratio of the Aid received (constant 2012 US$) of Heavily indebted poor countries in 1994 to that in 1995?
Offer a very short reply. 1.1. What is the ratio of the Aid received (constant 2012 US$) of Small states in 1994 to that in 1995?
Your answer should be very brief. 1.13. What is the ratio of the Aid received (constant 2012 US$) of St. Kitts and Nevis in 1994 to that in 1995?
Provide a succinct answer. 1.82. What is the ratio of the Aid received (constant 2012 US$) in Heavily indebted poor countries in 1994 to that in 1996?
Your response must be concise. 1.25. What is the ratio of the Aid received (constant 2012 US$) of Small states in 1994 to that in 1996?
Your response must be concise. 1.18. What is the ratio of the Aid received (constant 2012 US$) in Heavily indebted poor countries in 1995 to that in 1996?
Ensure brevity in your answer.  1.14. What is the ratio of the Aid received (constant 2012 US$) of Small states in 1995 to that in 1996?
Provide a succinct answer. 1.04. What is the ratio of the Aid received (constant 2012 US$) of St. Kitts and Nevis in 1995 to that in 1996?
Your response must be concise. 0.55. What is the difference between the highest and the second highest Aid received (constant 2012 US$) in Heavily indebted poor countries?
Offer a very short reply. 1.99e+08. What is the difference between the highest and the second highest Aid received (constant 2012 US$) of Small states?
Your answer should be very brief. 3.46e+08. What is the difference between the highest and the second highest Aid received (constant 2012 US$) of St. Kitts and Nevis?
Give a very brief answer. 6.94e+06. What is the difference between the highest and the lowest Aid received (constant 2012 US$) in Heavily indebted poor countries?
Make the answer very short. 5.22e+09. What is the difference between the highest and the lowest Aid received (constant 2012 US$) in Small states?
Provide a short and direct response. 8.99e+08. What is the difference between the highest and the lowest Aid received (constant 2012 US$) in St. Kitts and Nevis?
Provide a short and direct response. 1.82e+07. 